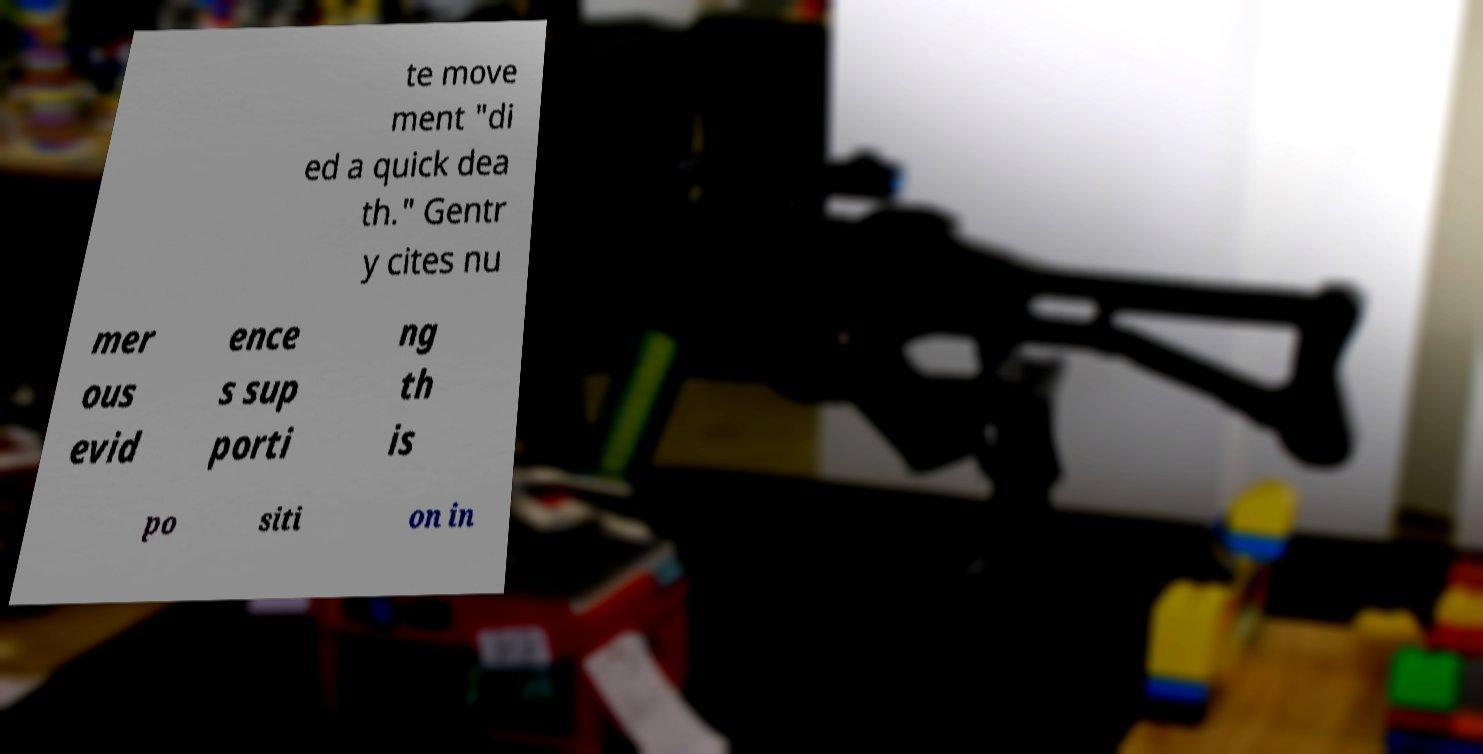For documentation purposes, I need the text within this image transcribed. Could you provide that? te move ment "di ed a quick dea th." Gentr y cites nu mer ous evid ence s sup porti ng th is po siti on in 